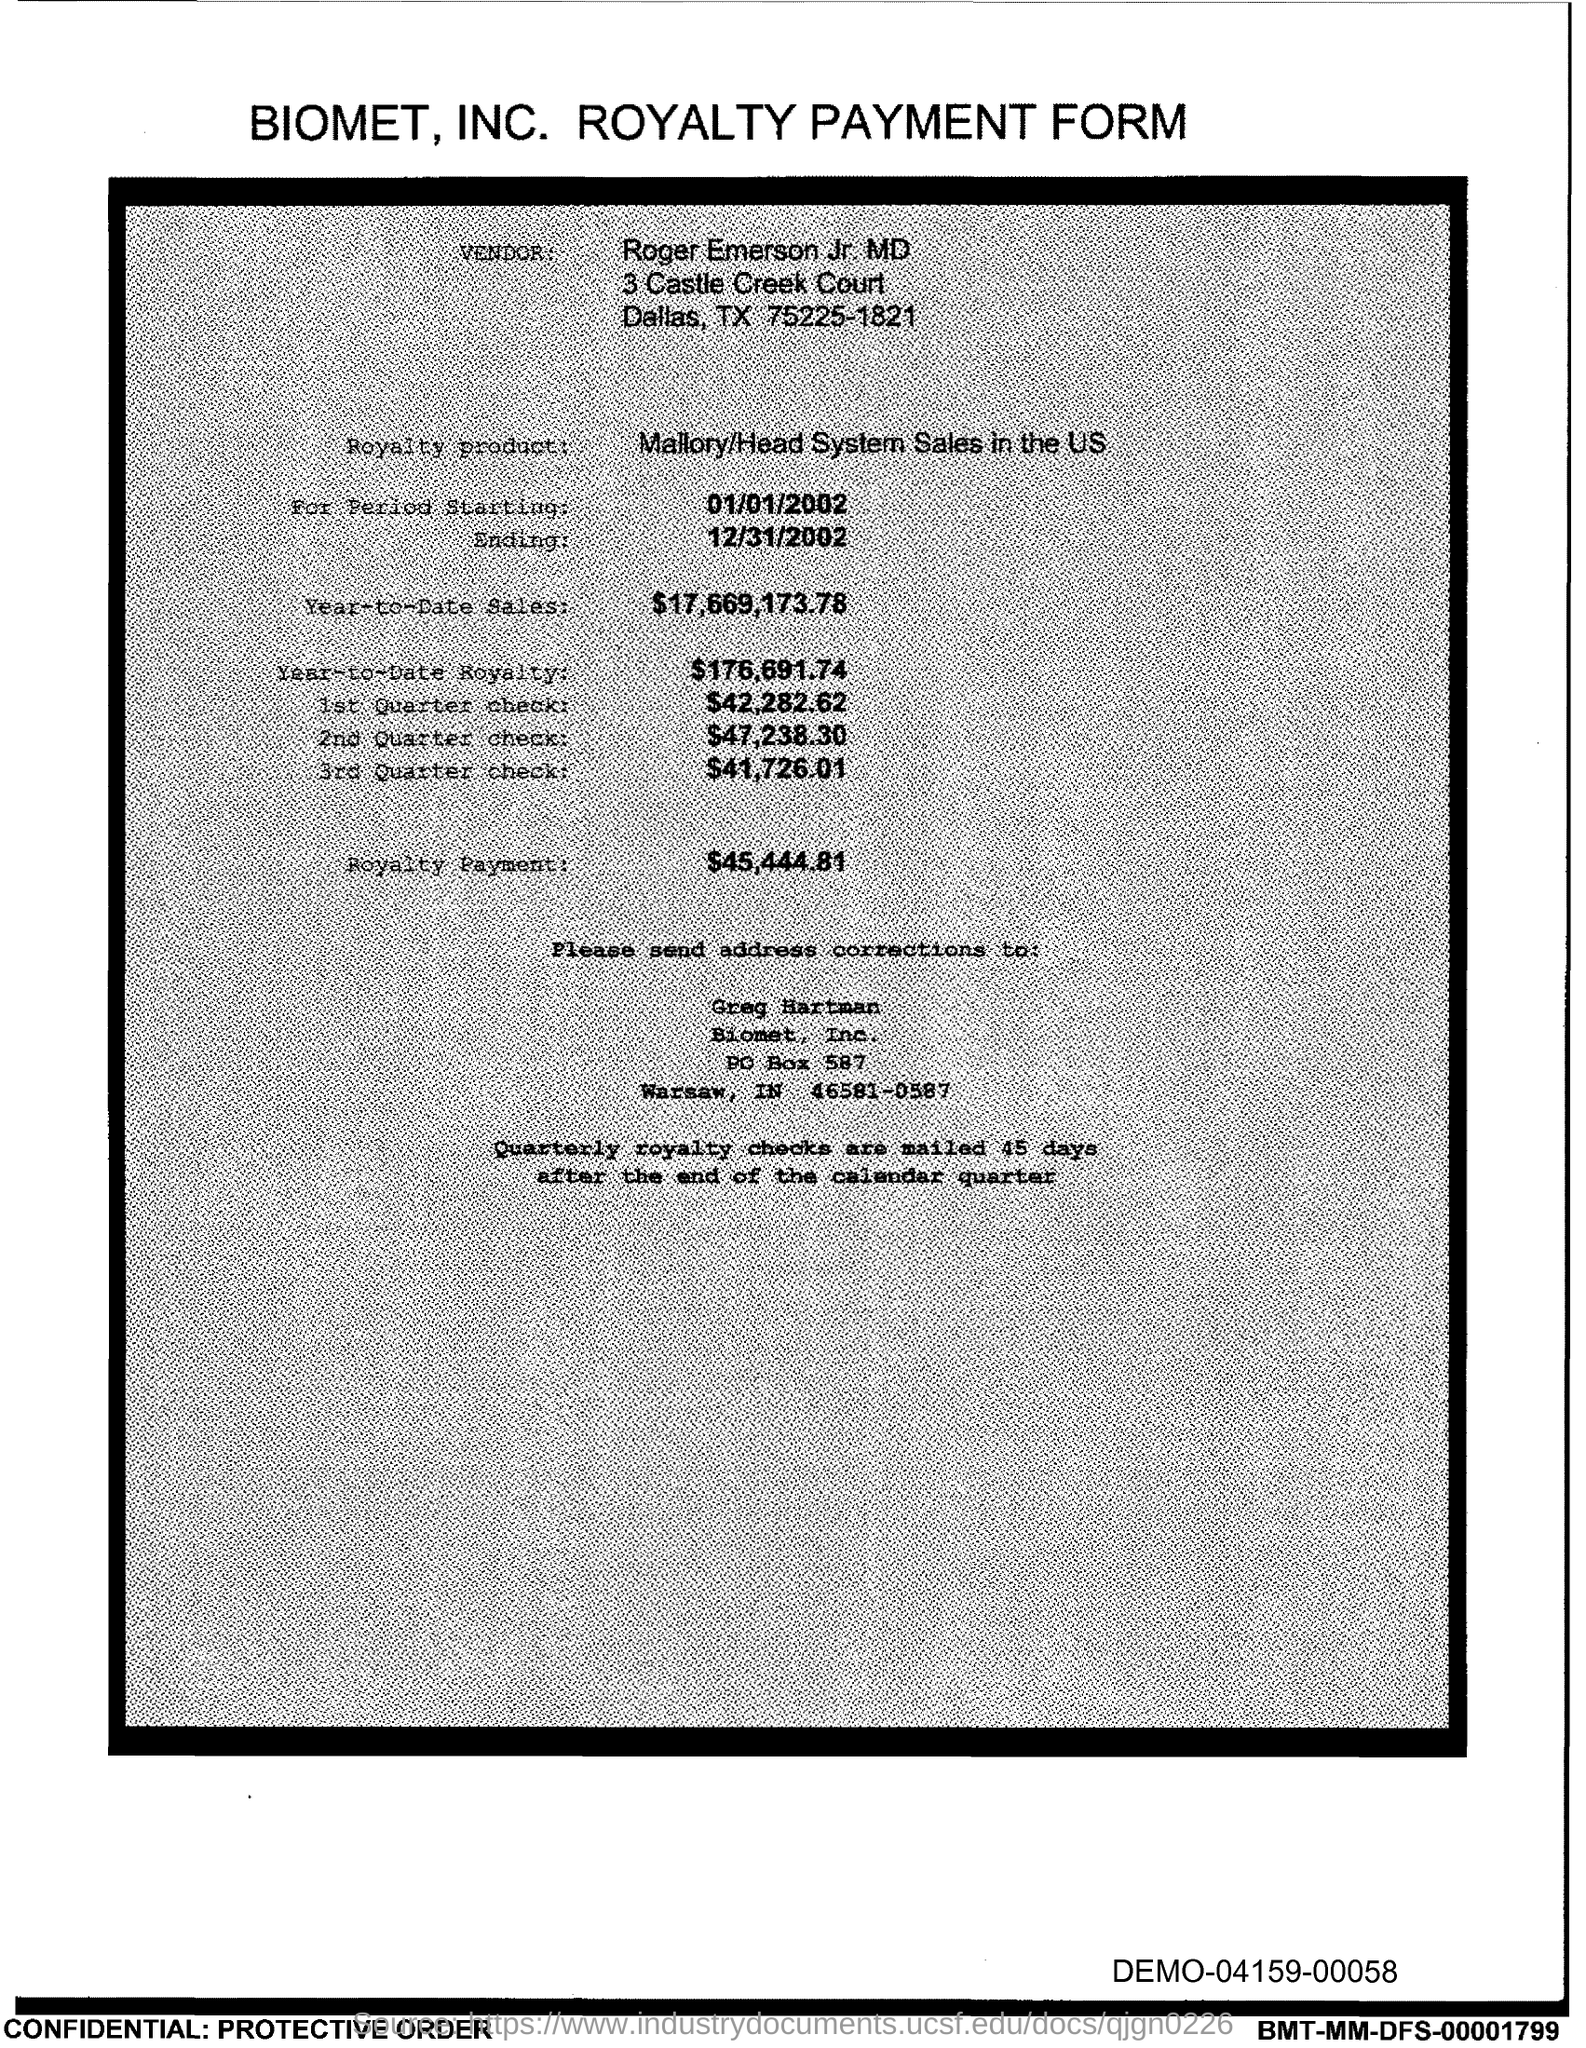What is the starting period mentioned?
Offer a very short reply. 01/01/2002. What is the ending period mentioned?
Provide a short and direct response. 12/31/2002. When are the royalty checks mailed?
Give a very brief answer. 45 days after the end of the calendar quarter. What is the name of the person to whom address corrections are send to?
Offer a very short reply. Greg Hartman. What is the royalty payment?
Give a very brief answer. $45,444.81. What is the 1st Quarter check?
Your response must be concise. $42,282.62. What is the 2nd Quarter check?
Ensure brevity in your answer.  $47,238.30. What is the 3rd Quarter check?
Your answer should be compact. $41,726.01. 